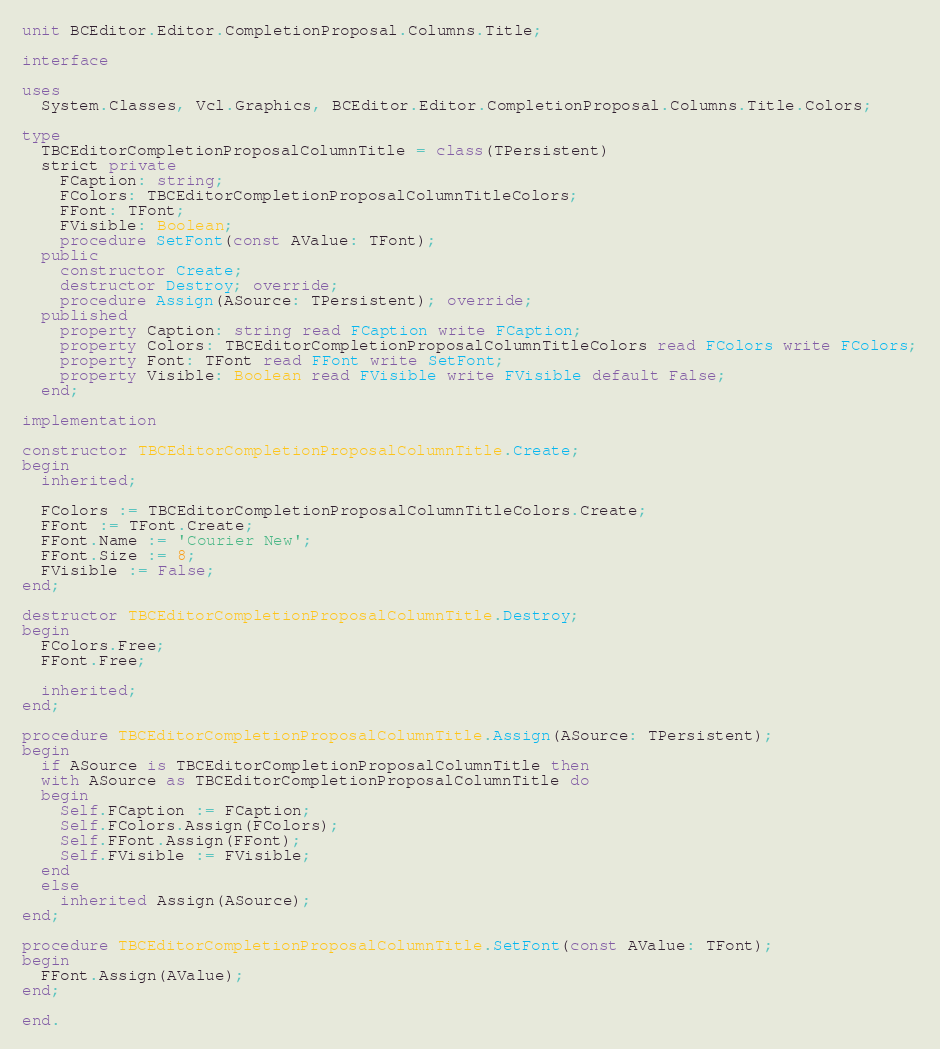<code> <loc_0><loc_0><loc_500><loc_500><_Pascal_>unit BCEditor.Editor.CompletionProposal.Columns.Title;

interface

uses
  System.Classes, Vcl.Graphics, BCEditor.Editor.CompletionProposal.Columns.Title.Colors;

type
  TBCEditorCompletionProposalColumnTitle = class(TPersistent)
  strict private
    FCaption: string;
    FColors: TBCEditorCompletionProposalColumnTitleColors;
    FFont: TFont;
    FVisible: Boolean;
    procedure SetFont(const AValue: TFont);
  public
    constructor Create;
    destructor Destroy; override;
    procedure Assign(ASource: TPersistent); override;
  published
    property Caption: string read FCaption write FCaption;
    property Colors: TBCEditorCompletionProposalColumnTitleColors read FColors write FColors;
    property Font: TFont read FFont write SetFont;
    property Visible: Boolean read FVisible write FVisible default False;
  end;

implementation

constructor TBCEditorCompletionProposalColumnTitle.Create;
begin
  inherited;

  FColors := TBCEditorCompletionProposalColumnTitleColors.Create;
  FFont := TFont.Create;
  FFont.Name := 'Courier New';
  FFont.Size := 8;
  FVisible := False;
end;

destructor TBCEditorCompletionProposalColumnTitle.Destroy;
begin
  FColors.Free;
  FFont.Free;

  inherited;
end;

procedure TBCEditorCompletionProposalColumnTitle.Assign(ASource: TPersistent);
begin
  if ASource is TBCEditorCompletionProposalColumnTitle then
  with ASource as TBCEditorCompletionProposalColumnTitle do
  begin
    Self.FCaption := FCaption;
    Self.FColors.Assign(FColors);
    Self.FFont.Assign(FFont);
    Self.FVisible := FVisible;
  end
  else
    inherited Assign(ASource);
end;

procedure TBCEditorCompletionProposalColumnTitle.SetFont(const AValue: TFont);
begin
  FFont.Assign(AValue);
end;

end.
</code> 